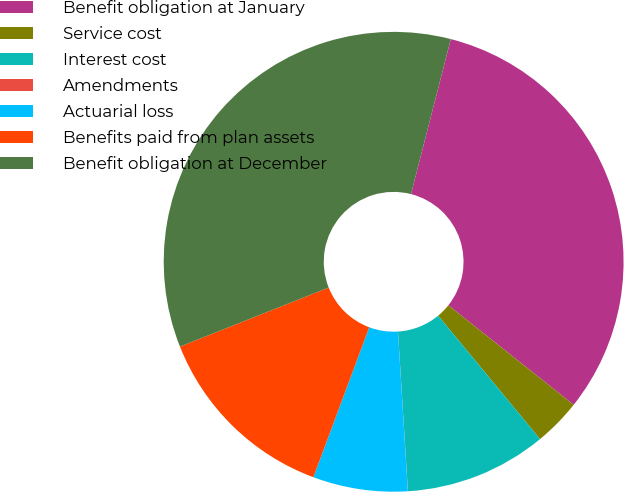Convert chart. <chart><loc_0><loc_0><loc_500><loc_500><pie_chart><fcel>Benefit obligation at January<fcel>Service cost<fcel>Interest cost<fcel>Amendments<fcel>Actuarial loss<fcel>Benefits paid from plan assets<fcel>Benefit obligation at December<nl><fcel>31.69%<fcel>3.33%<fcel>9.99%<fcel>0.01%<fcel>6.66%<fcel>13.31%<fcel>35.01%<nl></chart> 